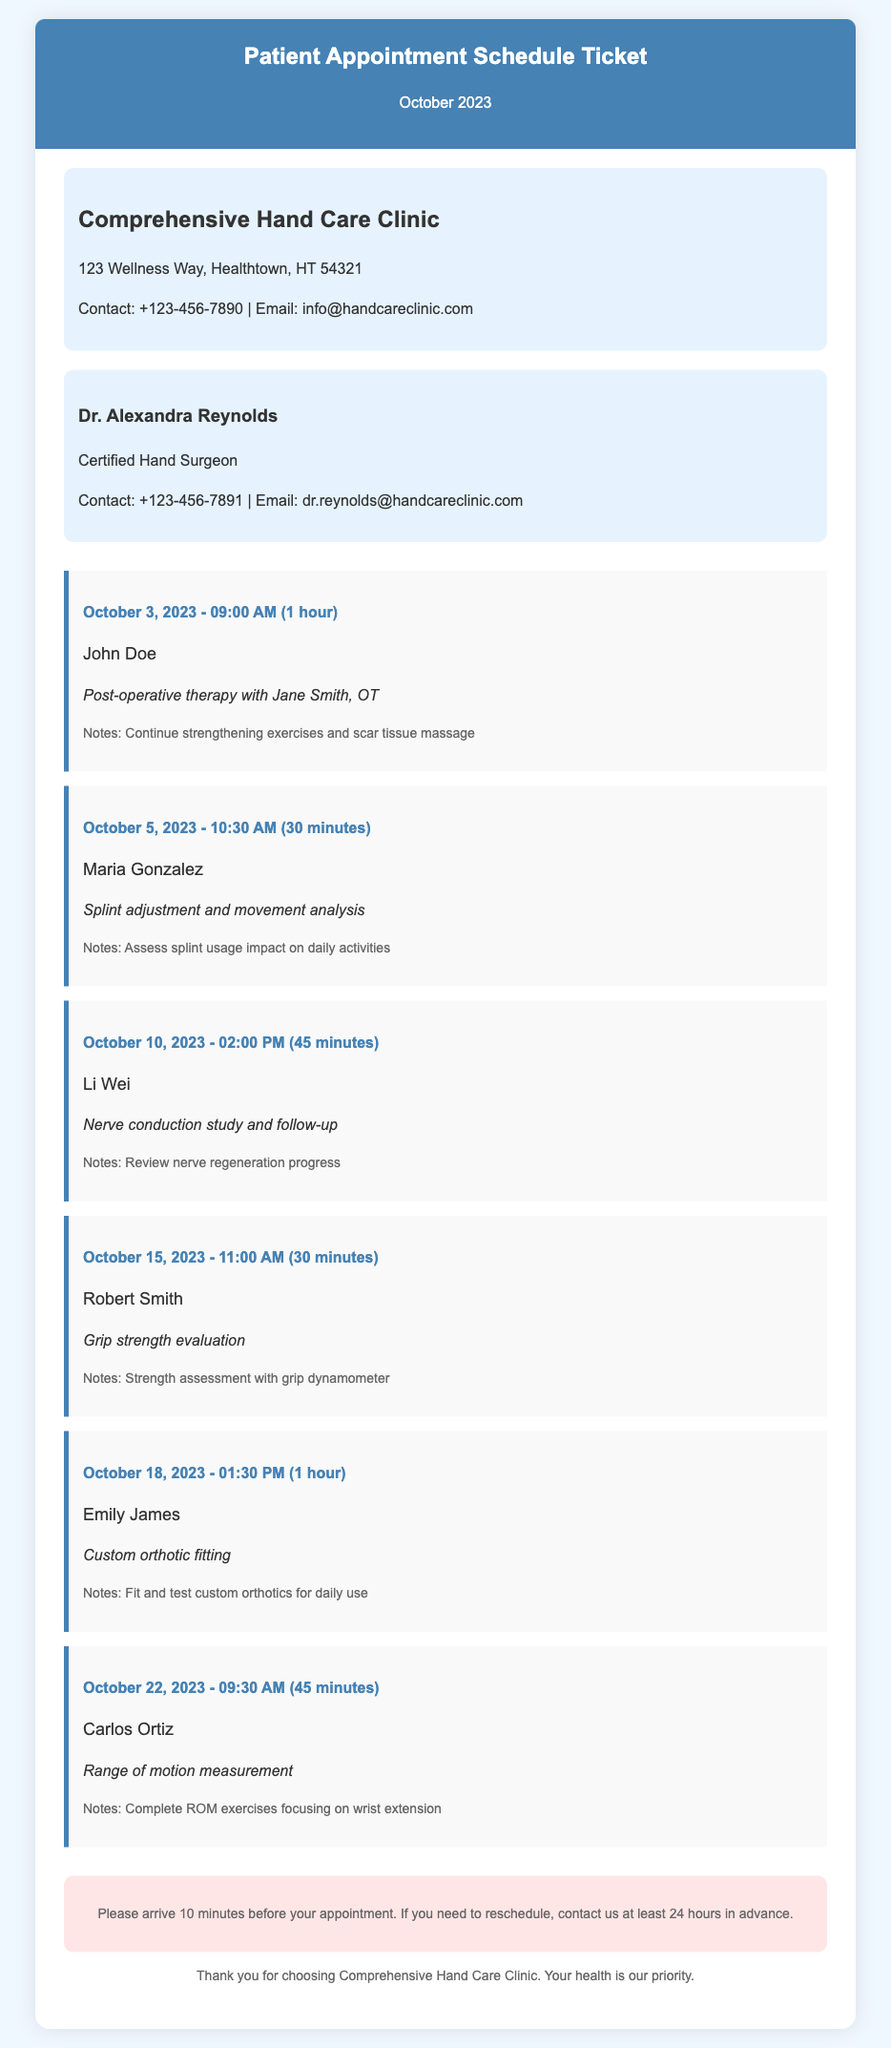What is the date and time of John Doe's appointment? The date and time of John Doe's appointment is specified as October 3, 2023 at 09:00 AM.
Answer: October 3, 2023 - 09:00 AM Who is the therapist for Maria Gonzalez's appointment? The document states that Maria Gonzalez's appointment involves splint adjustment and movement analysis, but does not specify a therapist.
Answer: Not specified How long is the appointment for Li Wei? The duration of Li Wei's appointment for nerve conduction study and follow-up is mentioned as 45 minutes.
Answer: 45 minutes What type of therapy is scheduled for Emily James? It is stated that Emily James's appointment involves custom orthotic fitting.
Answer: Custom orthotic fitting How many patients have appointments on October 22, 2023? The document lists only one patient, Carlos Ortiz, on October 22, 2023.
Answer: 1 What is the contact number for the Comprehensive Hand Care Clinic? The contact number for the clinic is provided in the document as +123-456-7890.
Answer: +123-456-7890 What is the purpose of Robert Smith's appointment? Robert Smith's appointment is for grip strength evaluation, as indicated in the appointment details.
Answer: Grip strength evaluation What is mentioned in the disclaimer at the bottom of the ticket? The disclaimer advises to arrive 10 minutes before the appointment and to reschedule 24 hours in advance if needed.
Answer: Arrive 10 minutes before appointment Who is the certified hand surgeon listed in the document? The document specifically lists Dr. Alexandra Reynolds as the certified hand surgeon.
Answer: Dr. Alexandra Reynolds 